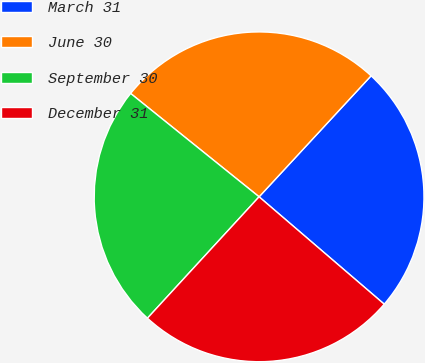Convert chart. <chart><loc_0><loc_0><loc_500><loc_500><pie_chart><fcel>March 31<fcel>June 30<fcel>September 30<fcel>December 31<nl><fcel>24.4%<fcel>26.1%<fcel>23.95%<fcel>25.55%<nl></chart> 